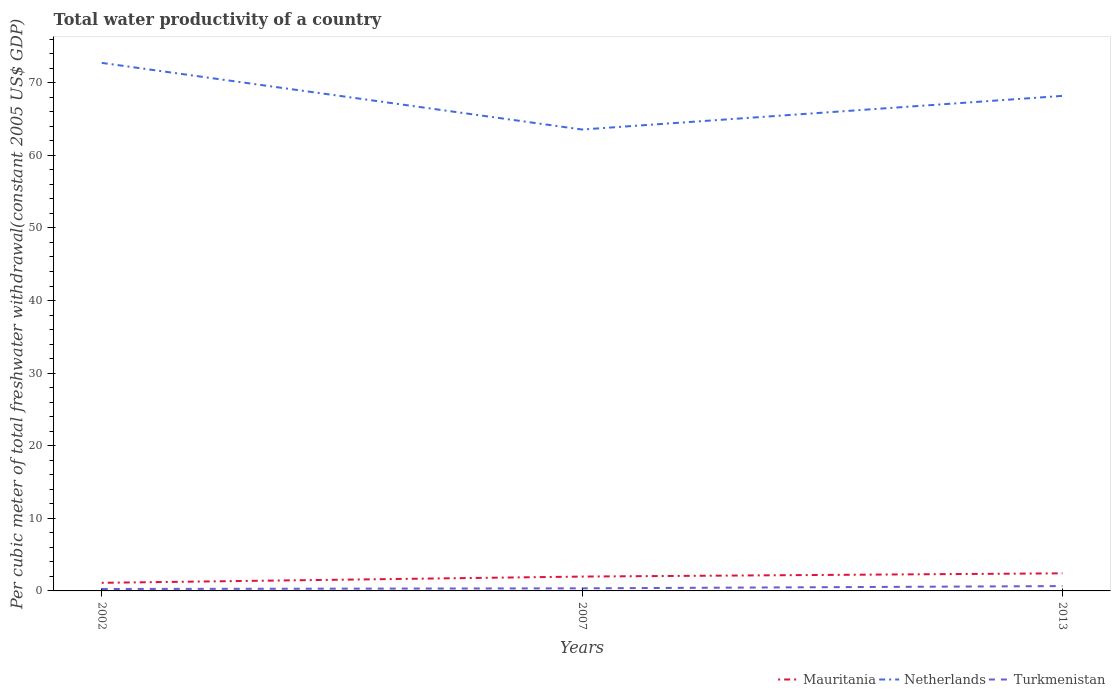Across all years, what is the maximum total water productivity in Mauritania?
Your answer should be very brief. 1.12. In which year was the total water productivity in Turkmenistan maximum?
Give a very brief answer. 2002. What is the total total water productivity in Netherlands in the graph?
Your answer should be compact. -4.63. What is the difference between the highest and the second highest total water productivity in Turkmenistan?
Make the answer very short. 0.4. What is the difference between the highest and the lowest total water productivity in Turkmenistan?
Make the answer very short. 1. Is the total water productivity in Turkmenistan strictly greater than the total water productivity in Netherlands over the years?
Your answer should be compact. Yes. How many lines are there?
Provide a short and direct response. 3. How many years are there in the graph?
Your answer should be very brief. 3. What is the difference between two consecutive major ticks on the Y-axis?
Your answer should be very brief. 10. Are the values on the major ticks of Y-axis written in scientific E-notation?
Your response must be concise. No. Does the graph contain grids?
Make the answer very short. No. How many legend labels are there?
Your response must be concise. 3. What is the title of the graph?
Offer a terse response. Total water productivity of a country. What is the label or title of the Y-axis?
Ensure brevity in your answer.  Per cubic meter of total freshwater withdrawal(constant 2005 US$ GDP). What is the Per cubic meter of total freshwater withdrawal(constant 2005 US$ GDP) in Mauritania in 2002?
Offer a very short reply. 1.12. What is the Per cubic meter of total freshwater withdrawal(constant 2005 US$ GDP) in Netherlands in 2002?
Your answer should be very brief. 72.74. What is the Per cubic meter of total freshwater withdrawal(constant 2005 US$ GDP) of Turkmenistan in 2002?
Make the answer very short. 0.27. What is the Per cubic meter of total freshwater withdrawal(constant 2005 US$ GDP) of Mauritania in 2007?
Keep it short and to the point. 1.98. What is the Per cubic meter of total freshwater withdrawal(constant 2005 US$ GDP) in Netherlands in 2007?
Give a very brief answer. 63.56. What is the Per cubic meter of total freshwater withdrawal(constant 2005 US$ GDP) in Turkmenistan in 2007?
Offer a very short reply. 0.36. What is the Per cubic meter of total freshwater withdrawal(constant 2005 US$ GDP) of Mauritania in 2013?
Make the answer very short. 2.42. What is the Per cubic meter of total freshwater withdrawal(constant 2005 US$ GDP) of Netherlands in 2013?
Offer a terse response. 68.19. What is the Per cubic meter of total freshwater withdrawal(constant 2005 US$ GDP) of Turkmenistan in 2013?
Offer a very short reply. 0.67. Across all years, what is the maximum Per cubic meter of total freshwater withdrawal(constant 2005 US$ GDP) in Mauritania?
Make the answer very short. 2.42. Across all years, what is the maximum Per cubic meter of total freshwater withdrawal(constant 2005 US$ GDP) of Netherlands?
Ensure brevity in your answer.  72.74. Across all years, what is the maximum Per cubic meter of total freshwater withdrawal(constant 2005 US$ GDP) of Turkmenistan?
Your answer should be very brief. 0.67. Across all years, what is the minimum Per cubic meter of total freshwater withdrawal(constant 2005 US$ GDP) in Mauritania?
Give a very brief answer. 1.12. Across all years, what is the minimum Per cubic meter of total freshwater withdrawal(constant 2005 US$ GDP) of Netherlands?
Your answer should be very brief. 63.56. Across all years, what is the minimum Per cubic meter of total freshwater withdrawal(constant 2005 US$ GDP) of Turkmenistan?
Keep it short and to the point. 0.27. What is the total Per cubic meter of total freshwater withdrawal(constant 2005 US$ GDP) of Mauritania in the graph?
Give a very brief answer. 5.52. What is the total Per cubic meter of total freshwater withdrawal(constant 2005 US$ GDP) in Netherlands in the graph?
Your answer should be compact. 204.49. What is the total Per cubic meter of total freshwater withdrawal(constant 2005 US$ GDP) of Turkmenistan in the graph?
Your response must be concise. 1.29. What is the difference between the Per cubic meter of total freshwater withdrawal(constant 2005 US$ GDP) in Mauritania in 2002 and that in 2007?
Offer a terse response. -0.86. What is the difference between the Per cubic meter of total freshwater withdrawal(constant 2005 US$ GDP) of Netherlands in 2002 and that in 2007?
Ensure brevity in your answer.  9.18. What is the difference between the Per cubic meter of total freshwater withdrawal(constant 2005 US$ GDP) of Turkmenistan in 2002 and that in 2007?
Offer a very short reply. -0.09. What is the difference between the Per cubic meter of total freshwater withdrawal(constant 2005 US$ GDP) in Mauritania in 2002 and that in 2013?
Ensure brevity in your answer.  -1.31. What is the difference between the Per cubic meter of total freshwater withdrawal(constant 2005 US$ GDP) of Netherlands in 2002 and that in 2013?
Ensure brevity in your answer.  4.55. What is the difference between the Per cubic meter of total freshwater withdrawal(constant 2005 US$ GDP) in Turkmenistan in 2002 and that in 2013?
Make the answer very short. -0.4. What is the difference between the Per cubic meter of total freshwater withdrawal(constant 2005 US$ GDP) of Mauritania in 2007 and that in 2013?
Keep it short and to the point. -0.45. What is the difference between the Per cubic meter of total freshwater withdrawal(constant 2005 US$ GDP) in Netherlands in 2007 and that in 2013?
Provide a short and direct response. -4.63. What is the difference between the Per cubic meter of total freshwater withdrawal(constant 2005 US$ GDP) in Turkmenistan in 2007 and that in 2013?
Ensure brevity in your answer.  -0.31. What is the difference between the Per cubic meter of total freshwater withdrawal(constant 2005 US$ GDP) of Mauritania in 2002 and the Per cubic meter of total freshwater withdrawal(constant 2005 US$ GDP) of Netherlands in 2007?
Offer a terse response. -62.44. What is the difference between the Per cubic meter of total freshwater withdrawal(constant 2005 US$ GDP) of Mauritania in 2002 and the Per cubic meter of total freshwater withdrawal(constant 2005 US$ GDP) of Turkmenistan in 2007?
Ensure brevity in your answer.  0.76. What is the difference between the Per cubic meter of total freshwater withdrawal(constant 2005 US$ GDP) in Netherlands in 2002 and the Per cubic meter of total freshwater withdrawal(constant 2005 US$ GDP) in Turkmenistan in 2007?
Your response must be concise. 72.38. What is the difference between the Per cubic meter of total freshwater withdrawal(constant 2005 US$ GDP) of Mauritania in 2002 and the Per cubic meter of total freshwater withdrawal(constant 2005 US$ GDP) of Netherlands in 2013?
Give a very brief answer. -67.07. What is the difference between the Per cubic meter of total freshwater withdrawal(constant 2005 US$ GDP) of Mauritania in 2002 and the Per cubic meter of total freshwater withdrawal(constant 2005 US$ GDP) of Turkmenistan in 2013?
Provide a succinct answer. 0.45. What is the difference between the Per cubic meter of total freshwater withdrawal(constant 2005 US$ GDP) of Netherlands in 2002 and the Per cubic meter of total freshwater withdrawal(constant 2005 US$ GDP) of Turkmenistan in 2013?
Make the answer very short. 72.07. What is the difference between the Per cubic meter of total freshwater withdrawal(constant 2005 US$ GDP) in Mauritania in 2007 and the Per cubic meter of total freshwater withdrawal(constant 2005 US$ GDP) in Netherlands in 2013?
Your answer should be very brief. -66.21. What is the difference between the Per cubic meter of total freshwater withdrawal(constant 2005 US$ GDP) in Mauritania in 2007 and the Per cubic meter of total freshwater withdrawal(constant 2005 US$ GDP) in Turkmenistan in 2013?
Make the answer very short. 1.31. What is the difference between the Per cubic meter of total freshwater withdrawal(constant 2005 US$ GDP) of Netherlands in 2007 and the Per cubic meter of total freshwater withdrawal(constant 2005 US$ GDP) of Turkmenistan in 2013?
Keep it short and to the point. 62.89. What is the average Per cubic meter of total freshwater withdrawal(constant 2005 US$ GDP) in Mauritania per year?
Offer a terse response. 1.84. What is the average Per cubic meter of total freshwater withdrawal(constant 2005 US$ GDP) in Netherlands per year?
Provide a succinct answer. 68.16. What is the average Per cubic meter of total freshwater withdrawal(constant 2005 US$ GDP) in Turkmenistan per year?
Provide a short and direct response. 0.43. In the year 2002, what is the difference between the Per cubic meter of total freshwater withdrawal(constant 2005 US$ GDP) in Mauritania and Per cubic meter of total freshwater withdrawal(constant 2005 US$ GDP) in Netherlands?
Give a very brief answer. -71.62. In the year 2002, what is the difference between the Per cubic meter of total freshwater withdrawal(constant 2005 US$ GDP) of Mauritania and Per cubic meter of total freshwater withdrawal(constant 2005 US$ GDP) of Turkmenistan?
Make the answer very short. 0.85. In the year 2002, what is the difference between the Per cubic meter of total freshwater withdrawal(constant 2005 US$ GDP) of Netherlands and Per cubic meter of total freshwater withdrawal(constant 2005 US$ GDP) of Turkmenistan?
Offer a terse response. 72.47. In the year 2007, what is the difference between the Per cubic meter of total freshwater withdrawal(constant 2005 US$ GDP) of Mauritania and Per cubic meter of total freshwater withdrawal(constant 2005 US$ GDP) of Netherlands?
Ensure brevity in your answer.  -61.58. In the year 2007, what is the difference between the Per cubic meter of total freshwater withdrawal(constant 2005 US$ GDP) in Mauritania and Per cubic meter of total freshwater withdrawal(constant 2005 US$ GDP) in Turkmenistan?
Make the answer very short. 1.62. In the year 2007, what is the difference between the Per cubic meter of total freshwater withdrawal(constant 2005 US$ GDP) of Netherlands and Per cubic meter of total freshwater withdrawal(constant 2005 US$ GDP) of Turkmenistan?
Offer a very short reply. 63.2. In the year 2013, what is the difference between the Per cubic meter of total freshwater withdrawal(constant 2005 US$ GDP) of Mauritania and Per cubic meter of total freshwater withdrawal(constant 2005 US$ GDP) of Netherlands?
Your answer should be very brief. -65.77. In the year 2013, what is the difference between the Per cubic meter of total freshwater withdrawal(constant 2005 US$ GDP) of Mauritania and Per cubic meter of total freshwater withdrawal(constant 2005 US$ GDP) of Turkmenistan?
Make the answer very short. 1.76. In the year 2013, what is the difference between the Per cubic meter of total freshwater withdrawal(constant 2005 US$ GDP) in Netherlands and Per cubic meter of total freshwater withdrawal(constant 2005 US$ GDP) in Turkmenistan?
Provide a short and direct response. 67.52. What is the ratio of the Per cubic meter of total freshwater withdrawal(constant 2005 US$ GDP) in Mauritania in 2002 to that in 2007?
Your answer should be very brief. 0.56. What is the ratio of the Per cubic meter of total freshwater withdrawal(constant 2005 US$ GDP) in Netherlands in 2002 to that in 2007?
Offer a terse response. 1.14. What is the ratio of the Per cubic meter of total freshwater withdrawal(constant 2005 US$ GDP) of Turkmenistan in 2002 to that in 2007?
Make the answer very short. 0.74. What is the ratio of the Per cubic meter of total freshwater withdrawal(constant 2005 US$ GDP) of Mauritania in 2002 to that in 2013?
Your response must be concise. 0.46. What is the ratio of the Per cubic meter of total freshwater withdrawal(constant 2005 US$ GDP) in Netherlands in 2002 to that in 2013?
Your answer should be compact. 1.07. What is the ratio of the Per cubic meter of total freshwater withdrawal(constant 2005 US$ GDP) of Turkmenistan in 2002 to that in 2013?
Your answer should be very brief. 0.4. What is the ratio of the Per cubic meter of total freshwater withdrawal(constant 2005 US$ GDP) in Mauritania in 2007 to that in 2013?
Offer a very short reply. 0.82. What is the ratio of the Per cubic meter of total freshwater withdrawal(constant 2005 US$ GDP) of Netherlands in 2007 to that in 2013?
Ensure brevity in your answer.  0.93. What is the ratio of the Per cubic meter of total freshwater withdrawal(constant 2005 US$ GDP) of Turkmenistan in 2007 to that in 2013?
Keep it short and to the point. 0.54. What is the difference between the highest and the second highest Per cubic meter of total freshwater withdrawal(constant 2005 US$ GDP) of Mauritania?
Provide a succinct answer. 0.45. What is the difference between the highest and the second highest Per cubic meter of total freshwater withdrawal(constant 2005 US$ GDP) in Netherlands?
Make the answer very short. 4.55. What is the difference between the highest and the second highest Per cubic meter of total freshwater withdrawal(constant 2005 US$ GDP) in Turkmenistan?
Ensure brevity in your answer.  0.31. What is the difference between the highest and the lowest Per cubic meter of total freshwater withdrawal(constant 2005 US$ GDP) of Mauritania?
Give a very brief answer. 1.31. What is the difference between the highest and the lowest Per cubic meter of total freshwater withdrawal(constant 2005 US$ GDP) in Netherlands?
Provide a short and direct response. 9.18. What is the difference between the highest and the lowest Per cubic meter of total freshwater withdrawal(constant 2005 US$ GDP) of Turkmenistan?
Ensure brevity in your answer.  0.4. 